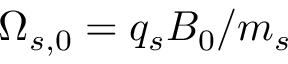<formula> <loc_0><loc_0><loc_500><loc_500>\Omega _ { s , 0 } = q _ { s } B _ { 0 } / m _ { s }</formula> 